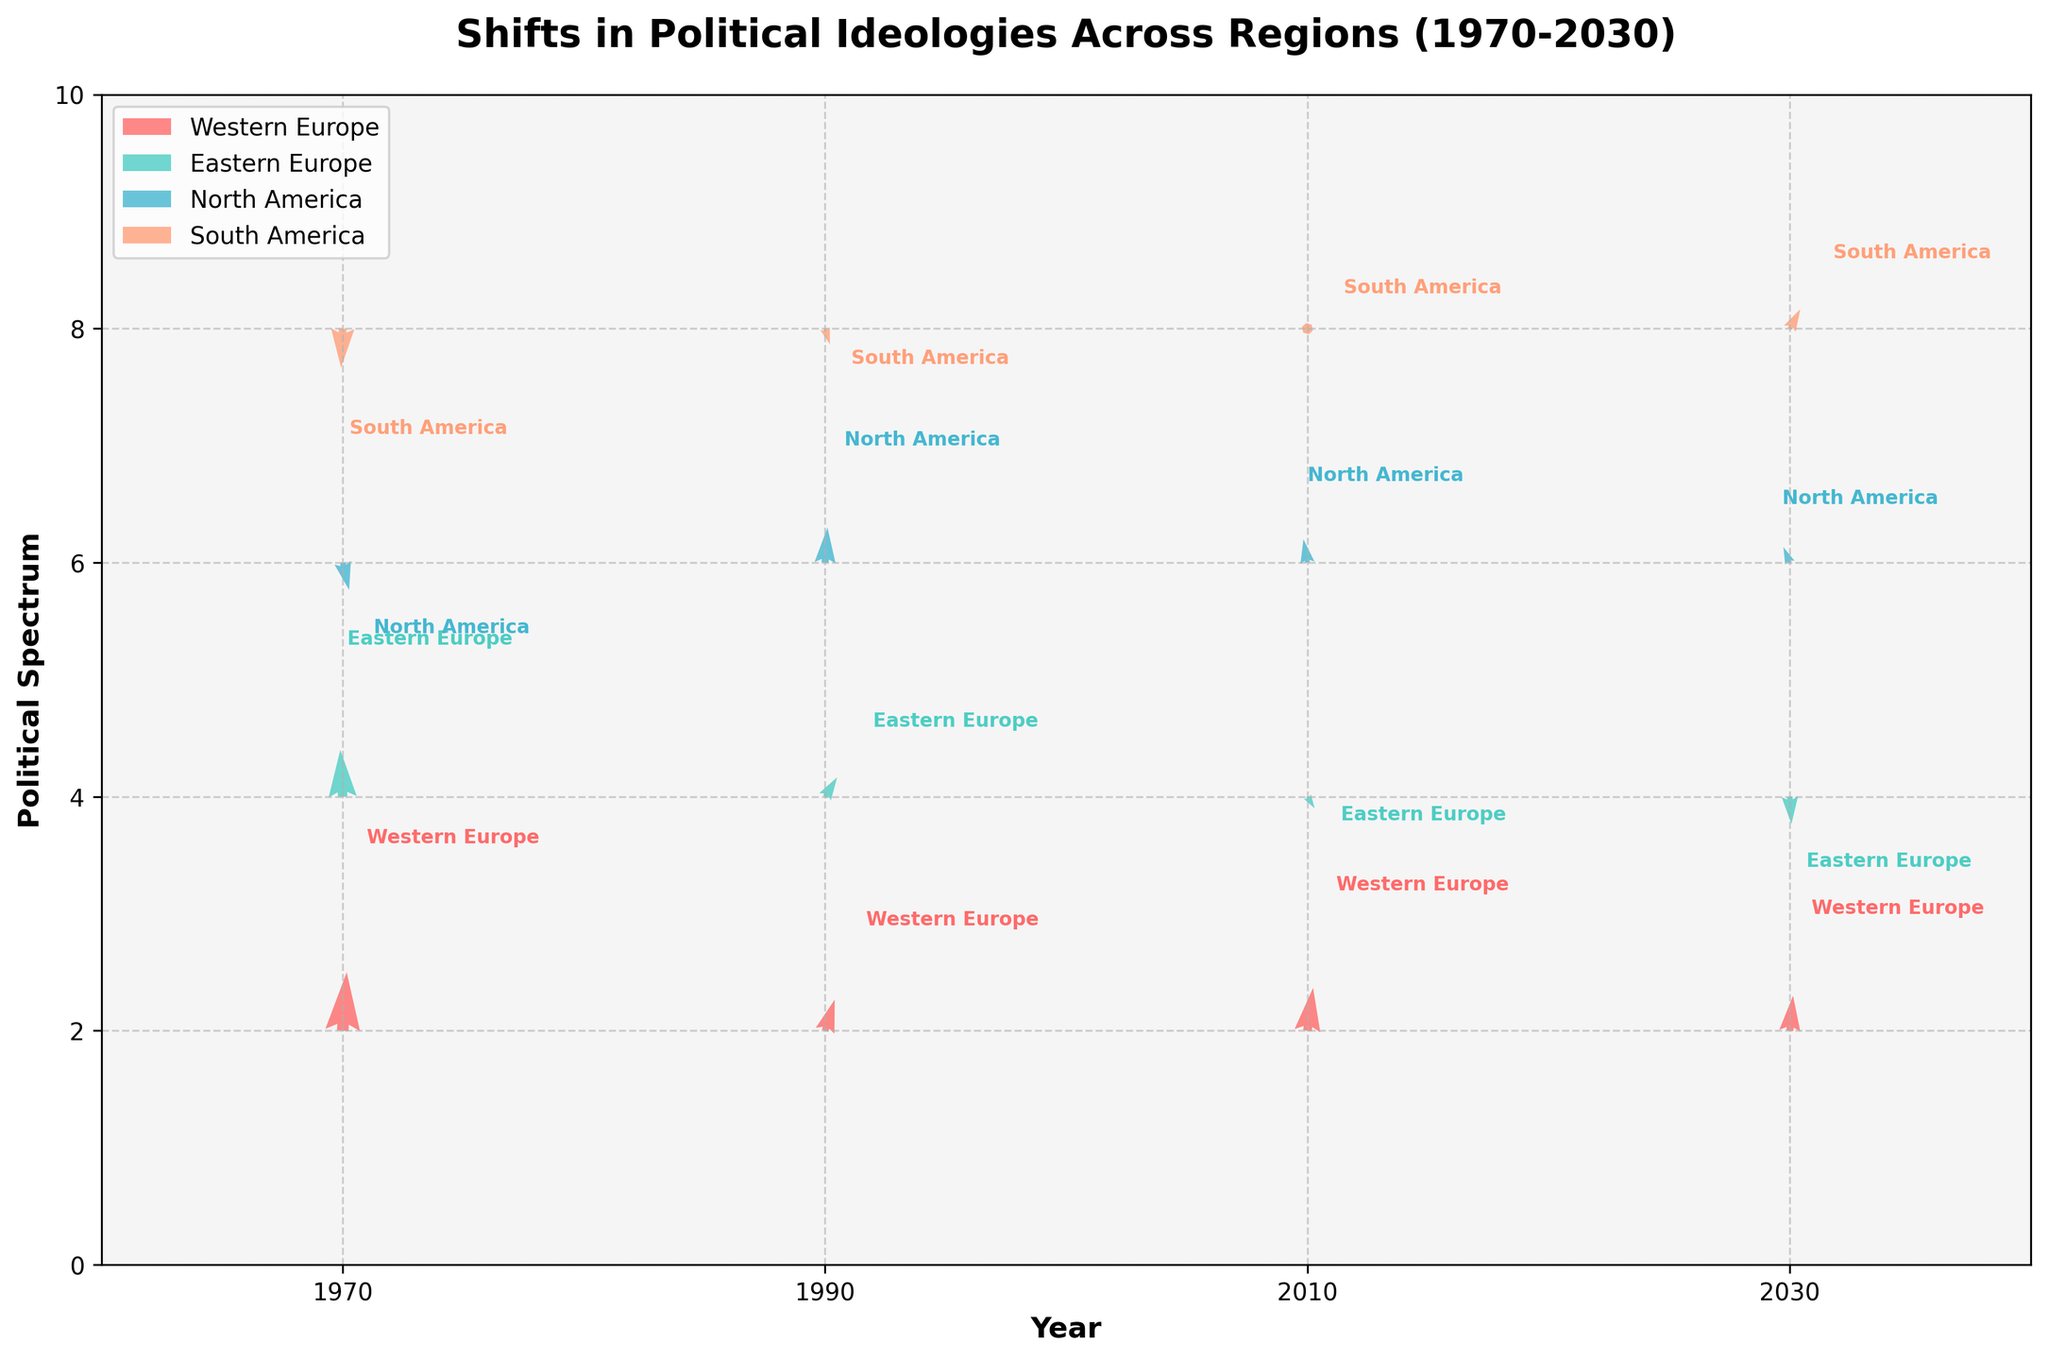What is the overall trend in political ideology shifts in Western Europe from 1970 to 2030? Observe the arrows representing Western Europe from 1970, 1990, 2010, and 2030. Each arrow shows a shift in political ideology over the years. All shifts point towards a positive change in both the x (time) and y (political spectrum) directions.
Answer: Positive shift What is the title of the figure showcasing the shifts in political ideologies? The title of the figure is displayed prominently at the top.
Answer: Shifts in Political Ideologies Across Regions (1970-2030) How does the shift in political ideology in Eastern Europe between 1990 and 2010 compare with the shift between 2010 and 2030 in terms of direction? Compare the direction of arrows for Eastern Europe between 1990 to 2010 and 2010 to 2030. Between 1990 and 2010, the shift is upward (positive y), while between 2010 and 2030, the shift is downward (negative y).
Answer: Opposite directions Which region shows the most significant shift in the political spectrum between 1970 and 2030? Compare the magnitude of arrows from 1970 to 2030 for all regions. South America, with an arrow length greater than others, shows the most significant shift.
Answer: South America Where do the political ideology shifts in North America seem to converge over the years? Observe the arrows for North America across different years. The arrows converge around a y-value of 6 over the years.
Answer: Around 6 What is the color used to represent Western Europe? Identify the colors used for different regions and match them accordingly.
Answer: Red How significant is the shift in North America's ideology from 2010 to 2030 compared to other years? Examine the arrow lengths representing shifts in North America for different years. The arrow from 2010 to 2030 shows a notable large shift, especially compared to previous years.
Answer: Very significant What is the direction of political ideology shift in South America from 1970 to 1990? Observe the arrow pointing from the position for South America in 1970 to its end point in 1990. The arrow points downwards, indicating a negative y shift.
Answer: Downward Which region displays consistent upward shifts in political spectrum over the years? Identify the arrows pointing upwards for all years. Western Europe consistently shows upward shifts.
Answer: Western Europe 